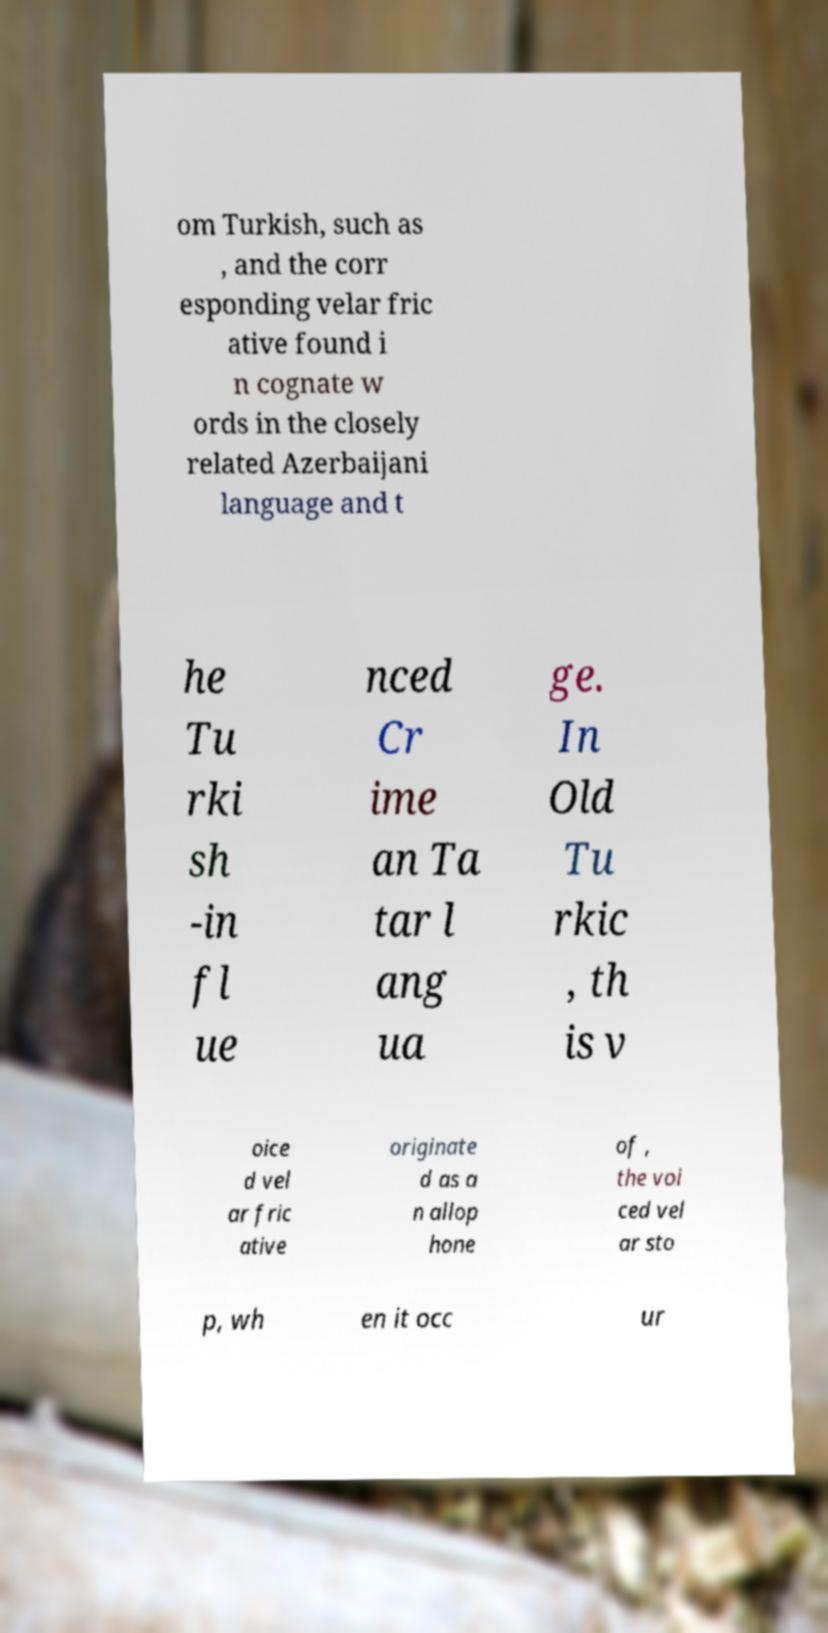I need the written content from this picture converted into text. Can you do that? om Turkish, such as , and the corr esponding velar fric ative found i n cognate w ords in the closely related Azerbaijani language and t he Tu rki sh -in fl ue nced Cr ime an Ta tar l ang ua ge. In Old Tu rkic , th is v oice d vel ar fric ative originate d as a n allop hone of , the voi ced vel ar sto p, wh en it occ ur 